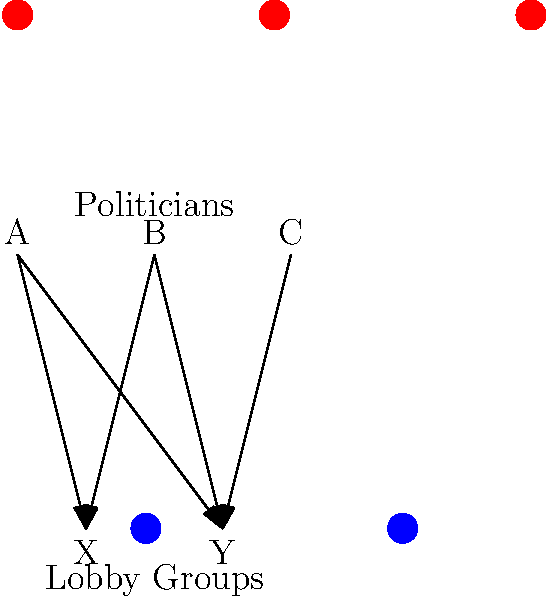In this bipartite network diagram showcasing the cozy relationship between politicians and lobby groups, which politician is the least "bought and paid for" by these special interests? Surely, they must be a paragon of virtue in this cesspool of influence peddling. Let's analyze this diagram of political puppetry step by step:

1. We have three politicians (A, B, and C) at the top and two lobby groups (X and Y) at the bottom.

2. The arrows indicate the flow of influence (and likely, money) from lobby groups to politicians.

3. Let's count the connections:
   - Politician A: 2 connections (to X and Y)
   - Politician B: 2 connections (to X and Y)
   - Politician C: 1 connection (to Y only)

4. Politician C has the least number of connections to lobby groups.

5. While one could argue that having fewer connections doesn't necessarily mean less corruption (quality over quantity, after all), in this simplified model, fewer connections imply less direct influence from lobby groups.

6. Therefore, in this diagram, Politician C appears to be the least influenced by the lobby groups shown.

Of course, in reality, this doesn't mean C is a beacon of integrity. They might just be holding out for a better offer or have connections to lobby groups not shown in this limited diagram.
Answer: Politician C 